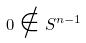<formula> <loc_0><loc_0><loc_500><loc_500>0 \notin S ^ { n - 1 }</formula> 